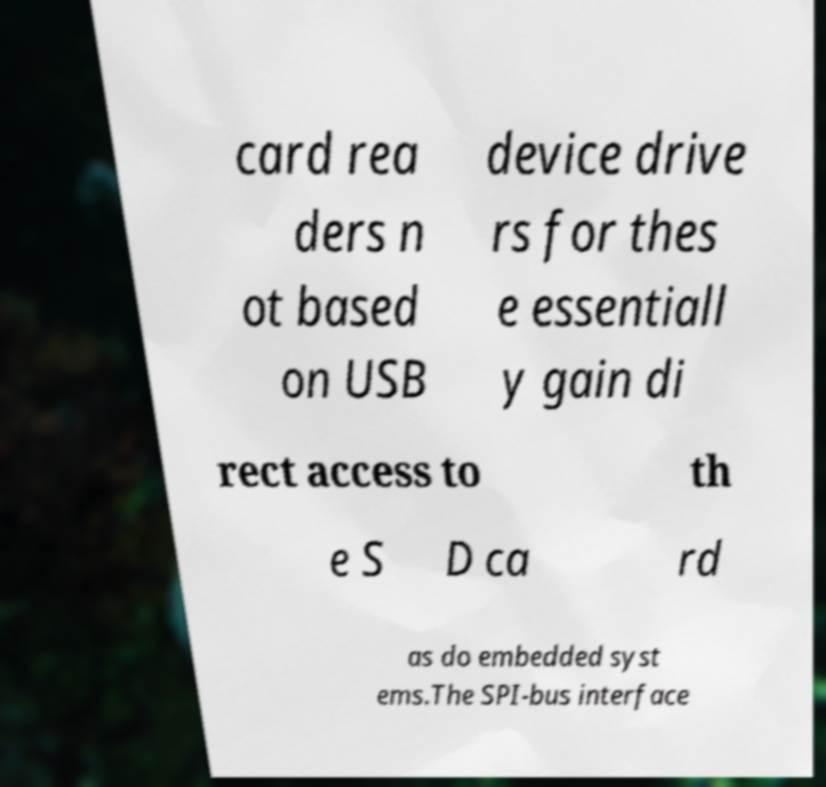There's text embedded in this image that I need extracted. Can you transcribe it verbatim? card rea ders n ot based on USB device drive rs for thes e essentiall y gain di rect access to th e S D ca rd as do embedded syst ems.The SPI-bus interface 